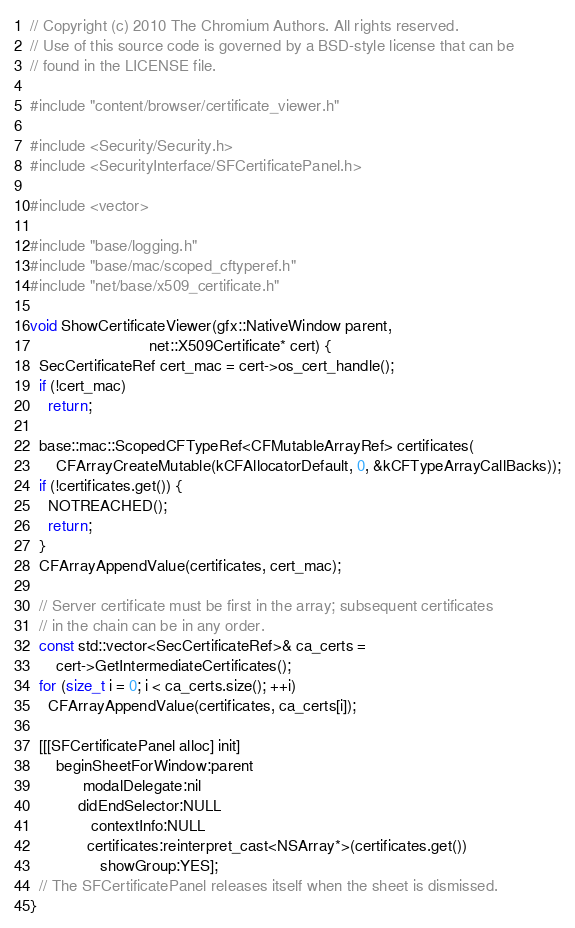<code> <loc_0><loc_0><loc_500><loc_500><_ObjectiveC_>// Copyright (c) 2010 The Chromium Authors. All rights reserved.
// Use of this source code is governed by a BSD-style license that can be
// found in the LICENSE file.

#include "content/browser/certificate_viewer.h"

#include <Security/Security.h>
#include <SecurityInterface/SFCertificatePanel.h>

#include <vector>

#include "base/logging.h"
#include "base/mac/scoped_cftyperef.h"
#include "net/base/x509_certificate.h"

void ShowCertificateViewer(gfx::NativeWindow parent,
                           net::X509Certificate* cert) {
  SecCertificateRef cert_mac = cert->os_cert_handle();
  if (!cert_mac)
    return;

  base::mac::ScopedCFTypeRef<CFMutableArrayRef> certificates(
      CFArrayCreateMutable(kCFAllocatorDefault, 0, &kCFTypeArrayCallBacks));
  if (!certificates.get()) {
    NOTREACHED();
    return;
  }
  CFArrayAppendValue(certificates, cert_mac);

  // Server certificate must be first in the array; subsequent certificates
  // in the chain can be in any order.
  const std::vector<SecCertificateRef>& ca_certs =
      cert->GetIntermediateCertificates();
  for (size_t i = 0; i < ca_certs.size(); ++i)
    CFArrayAppendValue(certificates, ca_certs[i]);

  [[[SFCertificatePanel alloc] init]
      beginSheetForWindow:parent
            modalDelegate:nil
           didEndSelector:NULL
              contextInfo:NULL
             certificates:reinterpret_cast<NSArray*>(certificates.get())
                showGroup:YES];
  // The SFCertificatePanel releases itself when the sheet is dismissed.
}
</code> 